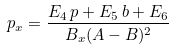<formula> <loc_0><loc_0><loc_500><loc_500>p _ { x } = \frac { E _ { 4 } \, p + E _ { 5 } \, b + E _ { 6 } } { B _ { x } ( A - B ) ^ { 2 } }</formula> 